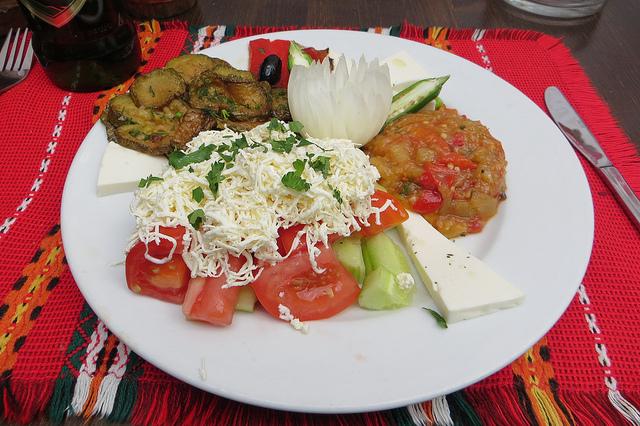How many kinds of food are on this plate?
Answer briefly. 6. Is there any cheese on this plate?
Quick response, please. Yes. Is this a plate in a home or restaurant?
Concise answer only. Restaurant. Has the food been eaten?
Give a very brief answer. No. What is the white stuff on the plate?
Short answer required. Cheese. What is printed on the placemat?
Quick response, please. Stripes. What color is the cloth the plate is sitting on?
Quick response, please. Red. What design feature does this table use?
Answer briefly. Placemat. 